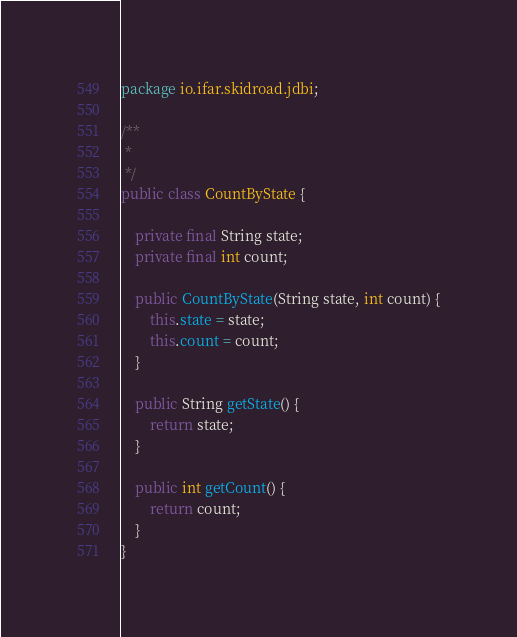<code> <loc_0><loc_0><loc_500><loc_500><_Java_>package io.ifar.skidroad.jdbi;

/**
 *
 */
public class CountByState {

    private final String state;
    private final int count;

    public CountByState(String state, int count) {
        this.state = state;
        this.count = count;
    }

    public String getState() {
        return state;
    }

    public int getCount() {
        return count;
    }
}
</code> 